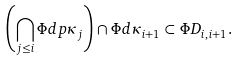Convert formula to latex. <formula><loc_0><loc_0><loc_500><loc_500>\left ( \bigcap _ { j \leq i } \Phi d p { \kappa _ { j } } \right ) \cap \Phi d { \kappa _ { i + 1 } } \subset \Phi D _ { i , i + 1 } .</formula> 